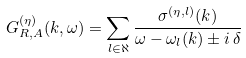<formula> <loc_0><loc_0><loc_500><loc_500>G _ { R , A } ^ { ( \eta ) } ( k , \omega ) = \sum _ { l \in \aleph } \frac { \sigma ^ { ( \eta , l ) } ( k ) } { \omega - \omega _ { l } ( k ) \pm i \, \delta }</formula> 